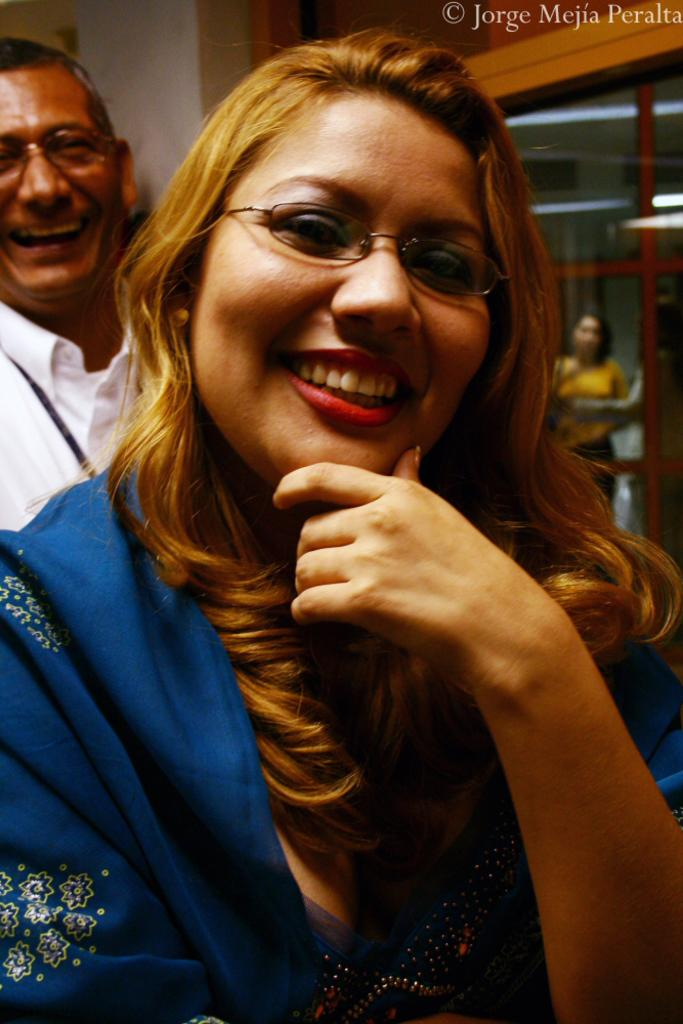Who or what is present in the image? There are people in the image. What is the facial expression of the people in the image? The people are smiling. What can be seen in the background of the image? There is a wall and a door in the background of the image. Where is the kitty hiding in the image? There is no kitty present in the image. What type of beast can be seen in the image? There are no beasts present in the image. 